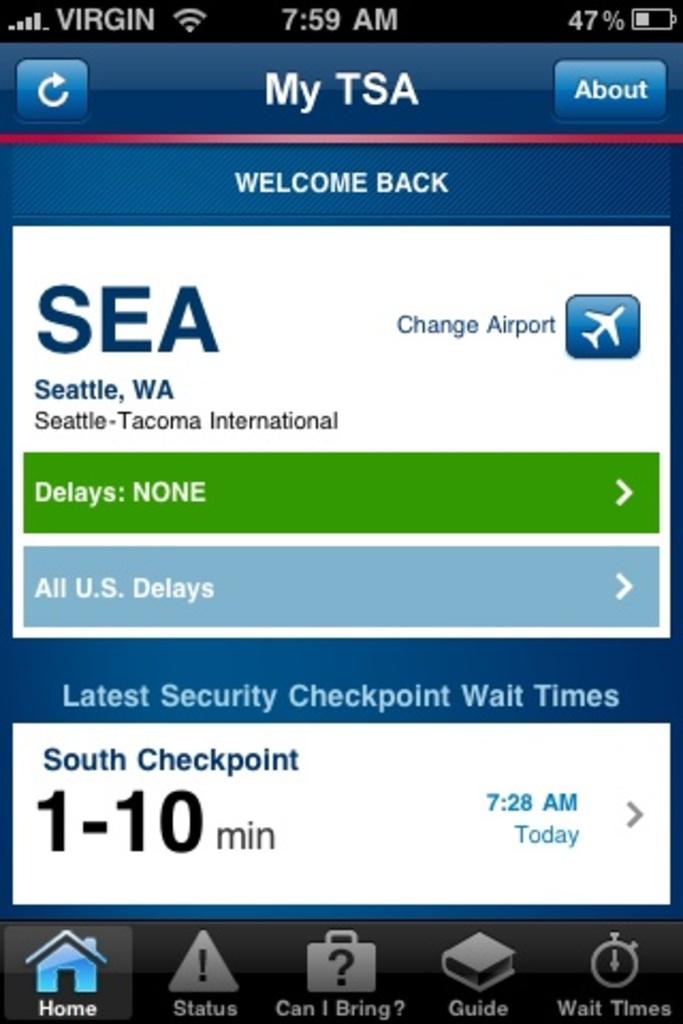What time is shown on the clock?
Provide a succinct answer. 7:59. What app is open?
Offer a terse response. My tsa. 